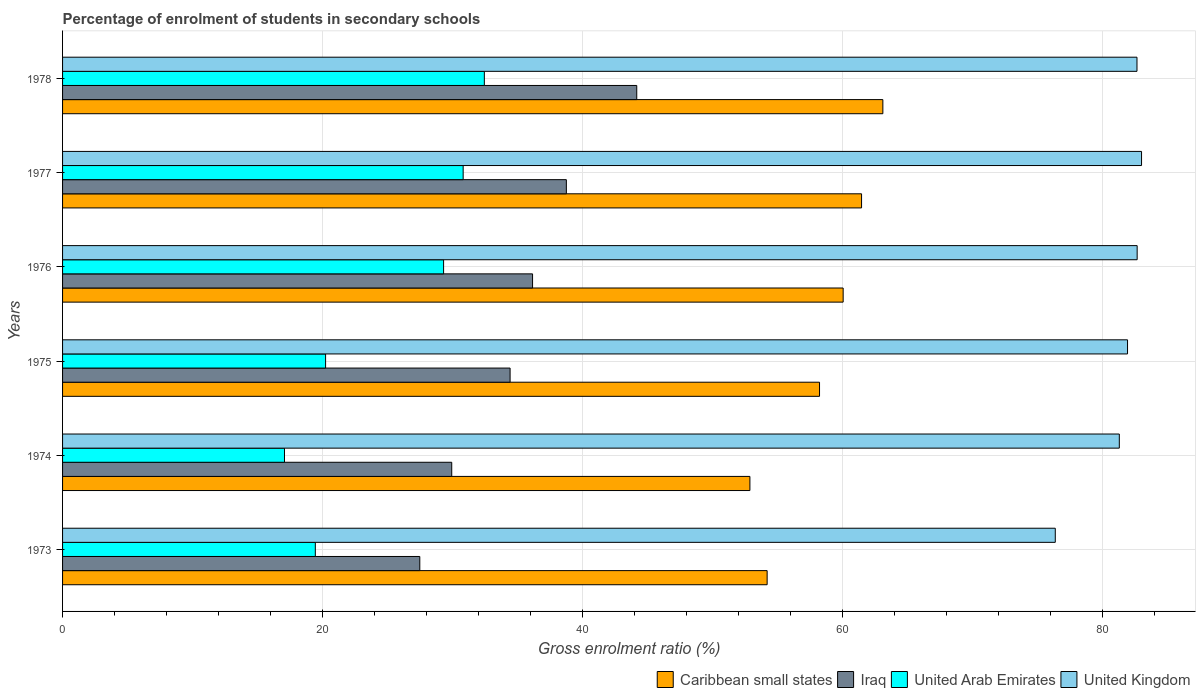How many groups of bars are there?
Your answer should be very brief. 6. In how many cases, is the number of bars for a given year not equal to the number of legend labels?
Provide a short and direct response. 0. What is the percentage of students enrolled in secondary schools in Caribbean small states in 1975?
Provide a short and direct response. 58.23. Across all years, what is the maximum percentage of students enrolled in secondary schools in United Kingdom?
Provide a succinct answer. 83. Across all years, what is the minimum percentage of students enrolled in secondary schools in United Arab Emirates?
Offer a very short reply. 17.07. In which year was the percentage of students enrolled in secondary schools in Iraq maximum?
Offer a very short reply. 1978. In which year was the percentage of students enrolled in secondary schools in Iraq minimum?
Give a very brief answer. 1973. What is the total percentage of students enrolled in secondary schools in Caribbean small states in the graph?
Ensure brevity in your answer.  349.92. What is the difference between the percentage of students enrolled in secondary schools in United Kingdom in 1974 and that in 1977?
Ensure brevity in your answer.  -1.71. What is the difference between the percentage of students enrolled in secondary schools in United Kingdom in 1977 and the percentage of students enrolled in secondary schools in Caribbean small states in 1974?
Provide a short and direct response. 30.13. What is the average percentage of students enrolled in secondary schools in United Arab Emirates per year?
Give a very brief answer. 24.89. In the year 1973, what is the difference between the percentage of students enrolled in secondary schools in United Arab Emirates and percentage of students enrolled in secondary schools in Caribbean small states?
Ensure brevity in your answer.  -34.76. What is the ratio of the percentage of students enrolled in secondary schools in United Kingdom in 1975 to that in 1977?
Offer a terse response. 0.99. Is the percentage of students enrolled in secondary schools in United Arab Emirates in 1973 less than that in 1975?
Offer a very short reply. Yes. Is the difference between the percentage of students enrolled in secondary schools in United Arab Emirates in 1975 and 1977 greater than the difference between the percentage of students enrolled in secondary schools in Caribbean small states in 1975 and 1977?
Provide a succinct answer. No. What is the difference between the highest and the second highest percentage of students enrolled in secondary schools in United Arab Emirates?
Give a very brief answer. 1.63. What is the difference between the highest and the lowest percentage of students enrolled in secondary schools in United Arab Emirates?
Make the answer very short. 15.37. Is the sum of the percentage of students enrolled in secondary schools in United Kingdom in 1973 and 1977 greater than the maximum percentage of students enrolled in secondary schools in United Arab Emirates across all years?
Offer a terse response. Yes. What does the 2nd bar from the top in 1976 represents?
Your answer should be compact. United Arab Emirates. What does the 1st bar from the bottom in 1974 represents?
Give a very brief answer. Caribbean small states. Is it the case that in every year, the sum of the percentage of students enrolled in secondary schools in United Kingdom and percentage of students enrolled in secondary schools in United Arab Emirates is greater than the percentage of students enrolled in secondary schools in Caribbean small states?
Keep it short and to the point. Yes. How many bars are there?
Keep it short and to the point. 24. How many years are there in the graph?
Your answer should be compact. 6. Does the graph contain any zero values?
Provide a short and direct response. No. Does the graph contain grids?
Make the answer very short. Yes. Where does the legend appear in the graph?
Give a very brief answer. Bottom right. What is the title of the graph?
Offer a very short reply. Percentage of enrolment of students in secondary schools. Does "Spain" appear as one of the legend labels in the graph?
Offer a terse response. No. What is the Gross enrolment ratio (%) of Caribbean small states in 1973?
Keep it short and to the point. 54.2. What is the Gross enrolment ratio (%) of Iraq in 1973?
Ensure brevity in your answer.  27.48. What is the Gross enrolment ratio (%) in United Arab Emirates in 1973?
Your answer should be compact. 19.44. What is the Gross enrolment ratio (%) of United Kingdom in 1973?
Keep it short and to the point. 76.37. What is the Gross enrolment ratio (%) in Caribbean small states in 1974?
Keep it short and to the point. 52.88. What is the Gross enrolment ratio (%) of Iraq in 1974?
Keep it short and to the point. 29.94. What is the Gross enrolment ratio (%) of United Arab Emirates in 1974?
Ensure brevity in your answer.  17.07. What is the Gross enrolment ratio (%) in United Kingdom in 1974?
Provide a succinct answer. 81.29. What is the Gross enrolment ratio (%) in Caribbean small states in 1975?
Your answer should be very brief. 58.23. What is the Gross enrolment ratio (%) of Iraq in 1975?
Your answer should be very brief. 34.43. What is the Gross enrolment ratio (%) in United Arab Emirates in 1975?
Offer a terse response. 20.23. What is the Gross enrolment ratio (%) in United Kingdom in 1975?
Provide a short and direct response. 81.92. What is the Gross enrolment ratio (%) of Caribbean small states in 1976?
Your answer should be very brief. 60.05. What is the Gross enrolment ratio (%) of Iraq in 1976?
Your answer should be compact. 36.16. What is the Gross enrolment ratio (%) in United Arab Emirates in 1976?
Keep it short and to the point. 29.31. What is the Gross enrolment ratio (%) of United Kingdom in 1976?
Your response must be concise. 82.66. What is the Gross enrolment ratio (%) in Caribbean small states in 1977?
Your answer should be very brief. 61.46. What is the Gross enrolment ratio (%) of Iraq in 1977?
Provide a short and direct response. 38.76. What is the Gross enrolment ratio (%) of United Arab Emirates in 1977?
Offer a very short reply. 30.82. What is the Gross enrolment ratio (%) of United Kingdom in 1977?
Give a very brief answer. 83. What is the Gross enrolment ratio (%) of Caribbean small states in 1978?
Keep it short and to the point. 63.1. What is the Gross enrolment ratio (%) in Iraq in 1978?
Provide a short and direct response. 44.17. What is the Gross enrolment ratio (%) in United Arab Emirates in 1978?
Offer a very short reply. 32.45. What is the Gross enrolment ratio (%) of United Kingdom in 1978?
Offer a very short reply. 82.65. Across all years, what is the maximum Gross enrolment ratio (%) of Caribbean small states?
Offer a terse response. 63.1. Across all years, what is the maximum Gross enrolment ratio (%) of Iraq?
Your response must be concise. 44.17. Across all years, what is the maximum Gross enrolment ratio (%) in United Arab Emirates?
Give a very brief answer. 32.45. Across all years, what is the maximum Gross enrolment ratio (%) of United Kingdom?
Offer a very short reply. 83. Across all years, what is the minimum Gross enrolment ratio (%) in Caribbean small states?
Offer a terse response. 52.88. Across all years, what is the minimum Gross enrolment ratio (%) of Iraq?
Ensure brevity in your answer.  27.48. Across all years, what is the minimum Gross enrolment ratio (%) of United Arab Emirates?
Offer a very short reply. 17.07. Across all years, what is the minimum Gross enrolment ratio (%) of United Kingdom?
Ensure brevity in your answer.  76.37. What is the total Gross enrolment ratio (%) of Caribbean small states in the graph?
Your response must be concise. 349.92. What is the total Gross enrolment ratio (%) in Iraq in the graph?
Make the answer very short. 210.93. What is the total Gross enrolment ratio (%) of United Arab Emirates in the graph?
Your answer should be very brief. 149.32. What is the total Gross enrolment ratio (%) of United Kingdom in the graph?
Give a very brief answer. 487.9. What is the difference between the Gross enrolment ratio (%) of Caribbean small states in 1973 and that in 1974?
Your response must be concise. 1.33. What is the difference between the Gross enrolment ratio (%) in Iraq in 1973 and that in 1974?
Give a very brief answer. -2.46. What is the difference between the Gross enrolment ratio (%) of United Arab Emirates in 1973 and that in 1974?
Make the answer very short. 2.37. What is the difference between the Gross enrolment ratio (%) of United Kingdom in 1973 and that in 1974?
Keep it short and to the point. -4.93. What is the difference between the Gross enrolment ratio (%) of Caribbean small states in 1973 and that in 1975?
Ensure brevity in your answer.  -4.03. What is the difference between the Gross enrolment ratio (%) in Iraq in 1973 and that in 1975?
Give a very brief answer. -6.95. What is the difference between the Gross enrolment ratio (%) of United Arab Emirates in 1973 and that in 1975?
Your answer should be compact. -0.79. What is the difference between the Gross enrolment ratio (%) in United Kingdom in 1973 and that in 1975?
Your answer should be very brief. -5.56. What is the difference between the Gross enrolment ratio (%) in Caribbean small states in 1973 and that in 1976?
Offer a very short reply. -5.85. What is the difference between the Gross enrolment ratio (%) of Iraq in 1973 and that in 1976?
Make the answer very short. -8.67. What is the difference between the Gross enrolment ratio (%) in United Arab Emirates in 1973 and that in 1976?
Provide a succinct answer. -9.87. What is the difference between the Gross enrolment ratio (%) of United Kingdom in 1973 and that in 1976?
Provide a short and direct response. -6.3. What is the difference between the Gross enrolment ratio (%) of Caribbean small states in 1973 and that in 1977?
Offer a very short reply. -7.26. What is the difference between the Gross enrolment ratio (%) in Iraq in 1973 and that in 1977?
Keep it short and to the point. -11.27. What is the difference between the Gross enrolment ratio (%) in United Arab Emirates in 1973 and that in 1977?
Offer a very short reply. -11.37. What is the difference between the Gross enrolment ratio (%) in United Kingdom in 1973 and that in 1977?
Provide a short and direct response. -6.64. What is the difference between the Gross enrolment ratio (%) in Caribbean small states in 1973 and that in 1978?
Provide a short and direct response. -8.9. What is the difference between the Gross enrolment ratio (%) of Iraq in 1973 and that in 1978?
Your answer should be very brief. -16.69. What is the difference between the Gross enrolment ratio (%) in United Arab Emirates in 1973 and that in 1978?
Your answer should be very brief. -13. What is the difference between the Gross enrolment ratio (%) in United Kingdom in 1973 and that in 1978?
Give a very brief answer. -6.29. What is the difference between the Gross enrolment ratio (%) in Caribbean small states in 1974 and that in 1975?
Your answer should be very brief. -5.36. What is the difference between the Gross enrolment ratio (%) in Iraq in 1974 and that in 1975?
Keep it short and to the point. -4.49. What is the difference between the Gross enrolment ratio (%) of United Arab Emirates in 1974 and that in 1975?
Provide a succinct answer. -3.16. What is the difference between the Gross enrolment ratio (%) in United Kingdom in 1974 and that in 1975?
Provide a short and direct response. -0.63. What is the difference between the Gross enrolment ratio (%) in Caribbean small states in 1974 and that in 1976?
Your response must be concise. -7.17. What is the difference between the Gross enrolment ratio (%) in Iraq in 1974 and that in 1976?
Your response must be concise. -6.22. What is the difference between the Gross enrolment ratio (%) of United Arab Emirates in 1974 and that in 1976?
Ensure brevity in your answer.  -12.24. What is the difference between the Gross enrolment ratio (%) of United Kingdom in 1974 and that in 1976?
Make the answer very short. -1.37. What is the difference between the Gross enrolment ratio (%) of Caribbean small states in 1974 and that in 1977?
Ensure brevity in your answer.  -8.59. What is the difference between the Gross enrolment ratio (%) of Iraq in 1974 and that in 1977?
Offer a terse response. -8.82. What is the difference between the Gross enrolment ratio (%) in United Arab Emirates in 1974 and that in 1977?
Provide a short and direct response. -13.75. What is the difference between the Gross enrolment ratio (%) in United Kingdom in 1974 and that in 1977?
Make the answer very short. -1.71. What is the difference between the Gross enrolment ratio (%) of Caribbean small states in 1974 and that in 1978?
Your answer should be very brief. -10.23. What is the difference between the Gross enrolment ratio (%) of Iraq in 1974 and that in 1978?
Give a very brief answer. -14.23. What is the difference between the Gross enrolment ratio (%) in United Arab Emirates in 1974 and that in 1978?
Provide a succinct answer. -15.37. What is the difference between the Gross enrolment ratio (%) in United Kingdom in 1974 and that in 1978?
Provide a short and direct response. -1.36. What is the difference between the Gross enrolment ratio (%) in Caribbean small states in 1975 and that in 1976?
Your response must be concise. -1.82. What is the difference between the Gross enrolment ratio (%) in Iraq in 1975 and that in 1976?
Offer a terse response. -1.73. What is the difference between the Gross enrolment ratio (%) of United Arab Emirates in 1975 and that in 1976?
Provide a short and direct response. -9.08. What is the difference between the Gross enrolment ratio (%) of United Kingdom in 1975 and that in 1976?
Your answer should be very brief. -0.74. What is the difference between the Gross enrolment ratio (%) in Caribbean small states in 1975 and that in 1977?
Your answer should be very brief. -3.23. What is the difference between the Gross enrolment ratio (%) in Iraq in 1975 and that in 1977?
Make the answer very short. -4.33. What is the difference between the Gross enrolment ratio (%) in United Arab Emirates in 1975 and that in 1977?
Provide a short and direct response. -10.58. What is the difference between the Gross enrolment ratio (%) in United Kingdom in 1975 and that in 1977?
Offer a terse response. -1.08. What is the difference between the Gross enrolment ratio (%) of Caribbean small states in 1975 and that in 1978?
Provide a succinct answer. -4.87. What is the difference between the Gross enrolment ratio (%) in Iraq in 1975 and that in 1978?
Make the answer very short. -9.74. What is the difference between the Gross enrolment ratio (%) in United Arab Emirates in 1975 and that in 1978?
Your answer should be compact. -12.21. What is the difference between the Gross enrolment ratio (%) in United Kingdom in 1975 and that in 1978?
Your answer should be compact. -0.73. What is the difference between the Gross enrolment ratio (%) in Caribbean small states in 1976 and that in 1977?
Your answer should be compact. -1.42. What is the difference between the Gross enrolment ratio (%) of Iraq in 1976 and that in 1977?
Your response must be concise. -2.6. What is the difference between the Gross enrolment ratio (%) of United Arab Emirates in 1976 and that in 1977?
Give a very brief answer. -1.51. What is the difference between the Gross enrolment ratio (%) in United Kingdom in 1976 and that in 1977?
Ensure brevity in your answer.  -0.34. What is the difference between the Gross enrolment ratio (%) of Caribbean small states in 1976 and that in 1978?
Keep it short and to the point. -3.05. What is the difference between the Gross enrolment ratio (%) in Iraq in 1976 and that in 1978?
Your answer should be compact. -8.01. What is the difference between the Gross enrolment ratio (%) of United Arab Emirates in 1976 and that in 1978?
Provide a short and direct response. -3.14. What is the difference between the Gross enrolment ratio (%) in United Kingdom in 1976 and that in 1978?
Provide a short and direct response. 0.01. What is the difference between the Gross enrolment ratio (%) in Caribbean small states in 1977 and that in 1978?
Your response must be concise. -1.64. What is the difference between the Gross enrolment ratio (%) in Iraq in 1977 and that in 1978?
Offer a terse response. -5.41. What is the difference between the Gross enrolment ratio (%) of United Arab Emirates in 1977 and that in 1978?
Offer a very short reply. -1.63. What is the difference between the Gross enrolment ratio (%) of United Kingdom in 1977 and that in 1978?
Offer a very short reply. 0.35. What is the difference between the Gross enrolment ratio (%) in Caribbean small states in 1973 and the Gross enrolment ratio (%) in Iraq in 1974?
Make the answer very short. 24.26. What is the difference between the Gross enrolment ratio (%) in Caribbean small states in 1973 and the Gross enrolment ratio (%) in United Arab Emirates in 1974?
Provide a short and direct response. 37.13. What is the difference between the Gross enrolment ratio (%) of Caribbean small states in 1973 and the Gross enrolment ratio (%) of United Kingdom in 1974?
Keep it short and to the point. -27.09. What is the difference between the Gross enrolment ratio (%) of Iraq in 1973 and the Gross enrolment ratio (%) of United Arab Emirates in 1974?
Your response must be concise. 10.41. What is the difference between the Gross enrolment ratio (%) in Iraq in 1973 and the Gross enrolment ratio (%) in United Kingdom in 1974?
Ensure brevity in your answer.  -53.81. What is the difference between the Gross enrolment ratio (%) of United Arab Emirates in 1973 and the Gross enrolment ratio (%) of United Kingdom in 1974?
Offer a very short reply. -61.85. What is the difference between the Gross enrolment ratio (%) in Caribbean small states in 1973 and the Gross enrolment ratio (%) in Iraq in 1975?
Ensure brevity in your answer.  19.77. What is the difference between the Gross enrolment ratio (%) in Caribbean small states in 1973 and the Gross enrolment ratio (%) in United Arab Emirates in 1975?
Provide a succinct answer. 33.97. What is the difference between the Gross enrolment ratio (%) of Caribbean small states in 1973 and the Gross enrolment ratio (%) of United Kingdom in 1975?
Offer a very short reply. -27.72. What is the difference between the Gross enrolment ratio (%) of Iraq in 1973 and the Gross enrolment ratio (%) of United Arab Emirates in 1975?
Offer a terse response. 7.25. What is the difference between the Gross enrolment ratio (%) in Iraq in 1973 and the Gross enrolment ratio (%) in United Kingdom in 1975?
Keep it short and to the point. -54.44. What is the difference between the Gross enrolment ratio (%) in United Arab Emirates in 1973 and the Gross enrolment ratio (%) in United Kingdom in 1975?
Keep it short and to the point. -62.48. What is the difference between the Gross enrolment ratio (%) of Caribbean small states in 1973 and the Gross enrolment ratio (%) of Iraq in 1976?
Ensure brevity in your answer.  18.04. What is the difference between the Gross enrolment ratio (%) of Caribbean small states in 1973 and the Gross enrolment ratio (%) of United Arab Emirates in 1976?
Keep it short and to the point. 24.89. What is the difference between the Gross enrolment ratio (%) in Caribbean small states in 1973 and the Gross enrolment ratio (%) in United Kingdom in 1976?
Provide a succinct answer. -28.46. What is the difference between the Gross enrolment ratio (%) of Iraq in 1973 and the Gross enrolment ratio (%) of United Arab Emirates in 1976?
Provide a short and direct response. -1.83. What is the difference between the Gross enrolment ratio (%) of Iraq in 1973 and the Gross enrolment ratio (%) of United Kingdom in 1976?
Your response must be concise. -55.18. What is the difference between the Gross enrolment ratio (%) of United Arab Emirates in 1973 and the Gross enrolment ratio (%) of United Kingdom in 1976?
Give a very brief answer. -63.22. What is the difference between the Gross enrolment ratio (%) of Caribbean small states in 1973 and the Gross enrolment ratio (%) of Iraq in 1977?
Provide a short and direct response. 15.44. What is the difference between the Gross enrolment ratio (%) in Caribbean small states in 1973 and the Gross enrolment ratio (%) in United Arab Emirates in 1977?
Offer a terse response. 23.38. What is the difference between the Gross enrolment ratio (%) of Caribbean small states in 1973 and the Gross enrolment ratio (%) of United Kingdom in 1977?
Keep it short and to the point. -28.8. What is the difference between the Gross enrolment ratio (%) in Iraq in 1973 and the Gross enrolment ratio (%) in United Arab Emirates in 1977?
Ensure brevity in your answer.  -3.34. What is the difference between the Gross enrolment ratio (%) of Iraq in 1973 and the Gross enrolment ratio (%) of United Kingdom in 1977?
Give a very brief answer. -55.52. What is the difference between the Gross enrolment ratio (%) in United Arab Emirates in 1973 and the Gross enrolment ratio (%) in United Kingdom in 1977?
Your answer should be very brief. -63.56. What is the difference between the Gross enrolment ratio (%) of Caribbean small states in 1973 and the Gross enrolment ratio (%) of Iraq in 1978?
Provide a succinct answer. 10.03. What is the difference between the Gross enrolment ratio (%) of Caribbean small states in 1973 and the Gross enrolment ratio (%) of United Arab Emirates in 1978?
Make the answer very short. 21.75. What is the difference between the Gross enrolment ratio (%) in Caribbean small states in 1973 and the Gross enrolment ratio (%) in United Kingdom in 1978?
Keep it short and to the point. -28.45. What is the difference between the Gross enrolment ratio (%) in Iraq in 1973 and the Gross enrolment ratio (%) in United Arab Emirates in 1978?
Ensure brevity in your answer.  -4.97. What is the difference between the Gross enrolment ratio (%) in Iraq in 1973 and the Gross enrolment ratio (%) in United Kingdom in 1978?
Give a very brief answer. -55.17. What is the difference between the Gross enrolment ratio (%) of United Arab Emirates in 1973 and the Gross enrolment ratio (%) of United Kingdom in 1978?
Offer a terse response. -63.21. What is the difference between the Gross enrolment ratio (%) in Caribbean small states in 1974 and the Gross enrolment ratio (%) in Iraq in 1975?
Offer a very short reply. 18.45. What is the difference between the Gross enrolment ratio (%) of Caribbean small states in 1974 and the Gross enrolment ratio (%) of United Arab Emirates in 1975?
Give a very brief answer. 32.64. What is the difference between the Gross enrolment ratio (%) of Caribbean small states in 1974 and the Gross enrolment ratio (%) of United Kingdom in 1975?
Your answer should be very brief. -29.05. What is the difference between the Gross enrolment ratio (%) of Iraq in 1974 and the Gross enrolment ratio (%) of United Arab Emirates in 1975?
Provide a succinct answer. 9.7. What is the difference between the Gross enrolment ratio (%) in Iraq in 1974 and the Gross enrolment ratio (%) in United Kingdom in 1975?
Provide a succinct answer. -51.99. What is the difference between the Gross enrolment ratio (%) in United Arab Emirates in 1974 and the Gross enrolment ratio (%) in United Kingdom in 1975?
Offer a very short reply. -64.85. What is the difference between the Gross enrolment ratio (%) in Caribbean small states in 1974 and the Gross enrolment ratio (%) in Iraq in 1976?
Make the answer very short. 16.72. What is the difference between the Gross enrolment ratio (%) of Caribbean small states in 1974 and the Gross enrolment ratio (%) of United Arab Emirates in 1976?
Your answer should be compact. 23.56. What is the difference between the Gross enrolment ratio (%) in Caribbean small states in 1974 and the Gross enrolment ratio (%) in United Kingdom in 1976?
Offer a very short reply. -29.79. What is the difference between the Gross enrolment ratio (%) of Iraq in 1974 and the Gross enrolment ratio (%) of United Arab Emirates in 1976?
Provide a short and direct response. 0.63. What is the difference between the Gross enrolment ratio (%) in Iraq in 1974 and the Gross enrolment ratio (%) in United Kingdom in 1976?
Offer a terse response. -52.73. What is the difference between the Gross enrolment ratio (%) of United Arab Emirates in 1974 and the Gross enrolment ratio (%) of United Kingdom in 1976?
Provide a short and direct response. -65.59. What is the difference between the Gross enrolment ratio (%) of Caribbean small states in 1974 and the Gross enrolment ratio (%) of Iraq in 1977?
Your response must be concise. 14.12. What is the difference between the Gross enrolment ratio (%) in Caribbean small states in 1974 and the Gross enrolment ratio (%) in United Arab Emirates in 1977?
Ensure brevity in your answer.  22.06. What is the difference between the Gross enrolment ratio (%) of Caribbean small states in 1974 and the Gross enrolment ratio (%) of United Kingdom in 1977?
Your answer should be very brief. -30.13. What is the difference between the Gross enrolment ratio (%) in Iraq in 1974 and the Gross enrolment ratio (%) in United Arab Emirates in 1977?
Your answer should be very brief. -0.88. What is the difference between the Gross enrolment ratio (%) in Iraq in 1974 and the Gross enrolment ratio (%) in United Kingdom in 1977?
Provide a short and direct response. -53.06. What is the difference between the Gross enrolment ratio (%) in United Arab Emirates in 1974 and the Gross enrolment ratio (%) in United Kingdom in 1977?
Your response must be concise. -65.93. What is the difference between the Gross enrolment ratio (%) in Caribbean small states in 1974 and the Gross enrolment ratio (%) in Iraq in 1978?
Make the answer very short. 8.71. What is the difference between the Gross enrolment ratio (%) of Caribbean small states in 1974 and the Gross enrolment ratio (%) of United Arab Emirates in 1978?
Make the answer very short. 20.43. What is the difference between the Gross enrolment ratio (%) of Caribbean small states in 1974 and the Gross enrolment ratio (%) of United Kingdom in 1978?
Ensure brevity in your answer.  -29.78. What is the difference between the Gross enrolment ratio (%) in Iraq in 1974 and the Gross enrolment ratio (%) in United Arab Emirates in 1978?
Your answer should be compact. -2.51. What is the difference between the Gross enrolment ratio (%) in Iraq in 1974 and the Gross enrolment ratio (%) in United Kingdom in 1978?
Your answer should be very brief. -52.71. What is the difference between the Gross enrolment ratio (%) in United Arab Emirates in 1974 and the Gross enrolment ratio (%) in United Kingdom in 1978?
Give a very brief answer. -65.58. What is the difference between the Gross enrolment ratio (%) in Caribbean small states in 1975 and the Gross enrolment ratio (%) in Iraq in 1976?
Provide a succinct answer. 22.08. What is the difference between the Gross enrolment ratio (%) in Caribbean small states in 1975 and the Gross enrolment ratio (%) in United Arab Emirates in 1976?
Make the answer very short. 28.92. What is the difference between the Gross enrolment ratio (%) of Caribbean small states in 1975 and the Gross enrolment ratio (%) of United Kingdom in 1976?
Make the answer very short. -24.43. What is the difference between the Gross enrolment ratio (%) of Iraq in 1975 and the Gross enrolment ratio (%) of United Arab Emirates in 1976?
Keep it short and to the point. 5.12. What is the difference between the Gross enrolment ratio (%) in Iraq in 1975 and the Gross enrolment ratio (%) in United Kingdom in 1976?
Give a very brief answer. -48.24. What is the difference between the Gross enrolment ratio (%) in United Arab Emirates in 1975 and the Gross enrolment ratio (%) in United Kingdom in 1976?
Keep it short and to the point. -62.43. What is the difference between the Gross enrolment ratio (%) of Caribbean small states in 1975 and the Gross enrolment ratio (%) of Iraq in 1977?
Your response must be concise. 19.48. What is the difference between the Gross enrolment ratio (%) of Caribbean small states in 1975 and the Gross enrolment ratio (%) of United Arab Emirates in 1977?
Ensure brevity in your answer.  27.41. What is the difference between the Gross enrolment ratio (%) of Caribbean small states in 1975 and the Gross enrolment ratio (%) of United Kingdom in 1977?
Make the answer very short. -24.77. What is the difference between the Gross enrolment ratio (%) in Iraq in 1975 and the Gross enrolment ratio (%) in United Arab Emirates in 1977?
Provide a succinct answer. 3.61. What is the difference between the Gross enrolment ratio (%) in Iraq in 1975 and the Gross enrolment ratio (%) in United Kingdom in 1977?
Your answer should be compact. -48.58. What is the difference between the Gross enrolment ratio (%) of United Arab Emirates in 1975 and the Gross enrolment ratio (%) of United Kingdom in 1977?
Make the answer very short. -62.77. What is the difference between the Gross enrolment ratio (%) of Caribbean small states in 1975 and the Gross enrolment ratio (%) of Iraq in 1978?
Keep it short and to the point. 14.06. What is the difference between the Gross enrolment ratio (%) of Caribbean small states in 1975 and the Gross enrolment ratio (%) of United Arab Emirates in 1978?
Ensure brevity in your answer.  25.78. What is the difference between the Gross enrolment ratio (%) of Caribbean small states in 1975 and the Gross enrolment ratio (%) of United Kingdom in 1978?
Offer a terse response. -24.42. What is the difference between the Gross enrolment ratio (%) of Iraq in 1975 and the Gross enrolment ratio (%) of United Arab Emirates in 1978?
Provide a short and direct response. 1.98. What is the difference between the Gross enrolment ratio (%) in Iraq in 1975 and the Gross enrolment ratio (%) in United Kingdom in 1978?
Provide a short and direct response. -48.23. What is the difference between the Gross enrolment ratio (%) of United Arab Emirates in 1975 and the Gross enrolment ratio (%) of United Kingdom in 1978?
Offer a very short reply. -62.42. What is the difference between the Gross enrolment ratio (%) of Caribbean small states in 1976 and the Gross enrolment ratio (%) of Iraq in 1977?
Keep it short and to the point. 21.29. What is the difference between the Gross enrolment ratio (%) of Caribbean small states in 1976 and the Gross enrolment ratio (%) of United Arab Emirates in 1977?
Your answer should be very brief. 29.23. What is the difference between the Gross enrolment ratio (%) of Caribbean small states in 1976 and the Gross enrolment ratio (%) of United Kingdom in 1977?
Your answer should be compact. -22.95. What is the difference between the Gross enrolment ratio (%) of Iraq in 1976 and the Gross enrolment ratio (%) of United Arab Emirates in 1977?
Ensure brevity in your answer.  5.34. What is the difference between the Gross enrolment ratio (%) of Iraq in 1976 and the Gross enrolment ratio (%) of United Kingdom in 1977?
Keep it short and to the point. -46.85. What is the difference between the Gross enrolment ratio (%) in United Arab Emirates in 1976 and the Gross enrolment ratio (%) in United Kingdom in 1977?
Ensure brevity in your answer.  -53.69. What is the difference between the Gross enrolment ratio (%) of Caribbean small states in 1976 and the Gross enrolment ratio (%) of Iraq in 1978?
Offer a very short reply. 15.88. What is the difference between the Gross enrolment ratio (%) in Caribbean small states in 1976 and the Gross enrolment ratio (%) in United Arab Emirates in 1978?
Your response must be concise. 27.6. What is the difference between the Gross enrolment ratio (%) of Caribbean small states in 1976 and the Gross enrolment ratio (%) of United Kingdom in 1978?
Your answer should be compact. -22.6. What is the difference between the Gross enrolment ratio (%) of Iraq in 1976 and the Gross enrolment ratio (%) of United Arab Emirates in 1978?
Your answer should be compact. 3.71. What is the difference between the Gross enrolment ratio (%) in Iraq in 1976 and the Gross enrolment ratio (%) in United Kingdom in 1978?
Keep it short and to the point. -46.5. What is the difference between the Gross enrolment ratio (%) of United Arab Emirates in 1976 and the Gross enrolment ratio (%) of United Kingdom in 1978?
Your answer should be compact. -53.34. What is the difference between the Gross enrolment ratio (%) in Caribbean small states in 1977 and the Gross enrolment ratio (%) in Iraq in 1978?
Your answer should be compact. 17.29. What is the difference between the Gross enrolment ratio (%) in Caribbean small states in 1977 and the Gross enrolment ratio (%) in United Arab Emirates in 1978?
Your answer should be very brief. 29.02. What is the difference between the Gross enrolment ratio (%) of Caribbean small states in 1977 and the Gross enrolment ratio (%) of United Kingdom in 1978?
Your answer should be very brief. -21.19. What is the difference between the Gross enrolment ratio (%) in Iraq in 1977 and the Gross enrolment ratio (%) in United Arab Emirates in 1978?
Provide a succinct answer. 6.31. What is the difference between the Gross enrolment ratio (%) in Iraq in 1977 and the Gross enrolment ratio (%) in United Kingdom in 1978?
Make the answer very short. -43.9. What is the difference between the Gross enrolment ratio (%) in United Arab Emirates in 1977 and the Gross enrolment ratio (%) in United Kingdom in 1978?
Keep it short and to the point. -51.84. What is the average Gross enrolment ratio (%) in Caribbean small states per year?
Your response must be concise. 58.32. What is the average Gross enrolment ratio (%) of Iraq per year?
Make the answer very short. 35.15. What is the average Gross enrolment ratio (%) in United Arab Emirates per year?
Keep it short and to the point. 24.89. What is the average Gross enrolment ratio (%) of United Kingdom per year?
Provide a short and direct response. 81.32. In the year 1973, what is the difference between the Gross enrolment ratio (%) in Caribbean small states and Gross enrolment ratio (%) in Iraq?
Your response must be concise. 26.72. In the year 1973, what is the difference between the Gross enrolment ratio (%) in Caribbean small states and Gross enrolment ratio (%) in United Arab Emirates?
Offer a terse response. 34.76. In the year 1973, what is the difference between the Gross enrolment ratio (%) in Caribbean small states and Gross enrolment ratio (%) in United Kingdom?
Make the answer very short. -22.17. In the year 1973, what is the difference between the Gross enrolment ratio (%) of Iraq and Gross enrolment ratio (%) of United Arab Emirates?
Keep it short and to the point. 8.04. In the year 1973, what is the difference between the Gross enrolment ratio (%) in Iraq and Gross enrolment ratio (%) in United Kingdom?
Provide a succinct answer. -48.89. In the year 1973, what is the difference between the Gross enrolment ratio (%) in United Arab Emirates and Gross enrolment ratio (%) in United Kingdom?
Keep it short and to the point. -56.92. In the year 1974, what is the difference between the Gross enrolment ratio (%) in Caribbean small states and Gross enrolment ratio (%) in Iraq?
Your answer should be compact. 22.94. In the year 1974, what is the difference between the Gross enrolment ratio (%) in Caribbean small states and Gross enrolment ratio (%) in United Arab Emirates?
Provide a succinct answer. 35.8. In the year 1974, what is the difference between the Gross enrolment ratio (%) of Caribbean small states and Gross enrolment ratio (%) of United Kingdom?
Ensure brevity in your answer.  -28.42. In the year 1974, what is the difference between the Gross enrolment ratio (%) of Iraq and Gross enrolment ratio (%) of United Arab Emirates?
Give a very brief answer. 12.87. In the year 1974, what is the difference between the Gross enrolment ratio (%) in Iraq and Gross enrolment ratio (%) in United Kingdom?
Make the answer very short. -51.35. In the year 1974, what is the difference between the Gross enrolment ratio (%) of United Arab Emirates and Gross enrolment ratio (%) of United Kingdom?
Keep it short and to the point. -64.22. In the year 1975, what is the difference between the Gross enrolment ratio (%) of Caribbean small states and Gross enrolment ratio (%) of Iraq?
Offer a very short reply. 23.8. In the year 1975, what is the difference between the Gross enrolment ratio (%) in Caribbean small states and Gross enrolment ratio (%) in United Arab Emirates?
Provide a succinct answer. 38. In the year 1975, what is the difference between the Gross enrolment ratio (%) of Caribbean small states and Gross enrolment ratio (%) of United Kingdom?
Offer a terse response. -23.69. In the year 1975, what is the difference between the Gross enrolment ratio (%) of Iraq and Gross enrolment ratio (%) of United Arab Emirates?
Give a very brief answer. 14.19. In the year 1975, what is the difference between the Gross enrolment ratio (%) of Iraq and Gross enrolment ratio (%) of United Kingdom?
Offer a very short reply. -47.5. In the year 1975, what is the difference between the Gross enrolment ratio (%) in United Arab Emirates and Gross enrolment ratio (%) in United Kingdom?
Your answer should be compact. -61.69. In the year 1976, what is the difference between the Gross enrolment ratio (%) of Caribbean small states and Gross enrolment ratio (%) of Iraq?
Ensure brevity in your answer.  23.89. In the year 1976, what is the difference between the Gross enrolment ratio (%) in Caribbean small states and Gross enrolment ratio (%) in United Arab Emirates?
Keep it short and to the point. 30.74. In the year 1976, what is the difference between the Gross enrolment ratio (%) in Caribbean small states and Gross enrolment ratio (%) in United Kingdom?
Offer a very short reply. -22.62. In the year 1976, what is the difference between the Gross enrolment ratio (%) in Iraq and Gross enrolment ratio (%) in United Arab Emirates?
Keep it short and to the point. 6.84. In the year 1976, what is the difference between the Gross enrolment ratio (%) of Iraq and Gross enrolment ratio (%) of United Kingdom?
Keep it short and to the point. -46.51. In the year 1976, what is the difference between the Gross enrolment ratio (%) in United Arab Emirates and Gross enrolment ratio (%) in United Kingdom?
Offer a very short reply. -53.35. In the year 1977, what is the difference between the Gross enrolment ratio (%) in Caribbean small states and Gross enrolment ratio (%) in Iraq?
Provide a succinct answer. 22.71. In the year 1977, what is the difference between the Gross enrolment ratio (%) of Caribbean small states and Gross enrolment ratio (%) of United Arab Emirates?
Provide a succinct answer. 30.65. In the year 1977, what is the difference between the Gross enrolment ratio (%) in Caribbean small states and Gross enrolment ratio (%) in United Kingdom?
Your answer should be compact. -21.54. In the year 1977, what is the difference between the Gross enrolment ratio (%) in Iraq and Gross enrolment ratio (%) in United Arab Emirates?
Offer a terse response. 7.94. In the year 1977, what is the difference between the Gross enrolment ratio (%) in Iraq and Gross enrolment ratio (%) in United Kingdom?
Offer a very short reply. -44.25. In the year 1977, what is the difference between the Gross enrolment ratio (%) in United Arab Emirates and Gross enrolment ratio (%) in United Kingdom?
Keep it short and to the point. -52.19. In the year 1978, what is the difference between the Gross enrolment ratio (%) of Caribbean small states and Gross enrolment ratio (%) of Iraq?
Your answer should be compact. 18.93. In the year 1978, what is the difference between the Gross enrolment ratio (%) in Caribbean small states and Gross enrolment ratio (%) in United Arab Emirates?
Your answer should be compact. 30.66. In the year 1978, what is the difference between the Gross enrolment ratio (%) of Caribbean small states and Gross enrolment ratio (%) of United Kingdom?
Offer a very short reply. -19.55. In the year 1978, what is the difference between the Gross enrolment ratio (%) of Iraq and Gross enrolment ratio (%) of United Arab Emirates?
Give a very brief answer. 11.72. In the year 1978, what is the difference between the Gross enrolment ratio (%) in Iraq and Gross enrolment ratio (%) in United Kingdom?
Keep it short and to the point. -38.48. In the year 1978, what is the difference between the Gross enrolment ratio (%) of United Arab Emirates and Gross enrolment ratio (%) of United Kingdom?
Offer a terse response. -50.21. What is the ratio of the Gross enrolment ratio (%) in Caribbean small states in 1973 to that in 1974?
Offer a very short reply. 1.03. What is the ratio of the Gross enrolment ratio (%) in Iraq in 1973 to that in 1974?
Provide a succinct answer. 0.92. What is the ratio of the Gross enrolment ratio (%) of United Arab Emirates in 1973 to that in 1974?
Ensure brevity in your answer.  1.14. What is the ratio of the Gross enrolment ratio (%) of United Kingdom in 1973 to that in 1974?
Ensure brevity in your answer.  0.94. What is the ratio of the Gross enrolment ratio (%) in Caribbean small states in 1973 to that in 1975?
Your answer should be very brief. 0.93. What is the ratio of the Gross enrolment ratio (%) of Iraq in 1973 to that in 1975?
Offer a very short reply. 0.8. What is the ratio of the Gross enrolment ratio (%) in United Arab Emirates in 1973 to that in 1975?
Keep it short and to the point. 0.96. What is the ratio of the Gross enrolment ratio (%) of United Kingdom in 1973 to that in 1975?
Make the answer very short. 0.93. What is the ratio of the Gross enrolment ratio (%) of Caribbean small states in 1973 to that in 1976?
Offer a terse response. 0.9. What is the ratio of the Gross enrolment ratio (%) in Iraq in 1973 to that in 1976?
Your response must be concise. 0.76. What is the ratio of the Gross enrolment ratio (%) in United Arab Emirates in 1973 to that in 1976?
Make the answer very short. 0.66. What is the ratio of the Gross enrolment ratio (%) of United Kingdom in 1973 to that in 1976?
Make the answer very short. 0.92. What is the ratio of the Gross enrolment ratio (%) of Caribbean small states in 1973 to that in 1977?
Your response must be concise. 0.88. What is the ratio of the Gross enrolment ratio (%) of Iraq in 1973 to that in 1977?
Ensure brevity in your answer.  0.71. What is the ratio of the Gross enrolment ratio (%) of United Arab Emirates in 1973 to that in 1977?
Provide a short and direct response. 0.63. What is the ratio of the Gross enrolment ratio (%) in Caribbean small states in 1973 to that in 1978?
Keep it short and to the point. 0.86. What is the ratio of the Gross enrolment ratio (%) in Iraq in 1973 to that in 1978?
Provide a succinct answer. 0.62. What is the ratio of the Gross enrolment ratio (%) in United Arab Emirates in 1973 to that in 1978?
Provide a short and direct response. 0.6. What is the ratio of the Gross enrolment ratio (%) in United Kingdom in 1973 to that in 1978?
Your answer should be very brief. 0.92. What is the ratio of the Gross enrolment ratio (%) of Caribbean small states in 1974 to that in 1975?
Your response must be concise. 0.91. What is the ratio of the Gross enrolment ratio (%) in Iraq in 1974 to that in 1975?
Your response must be concise. 0.87. What is the ratio of the Gross enrolment ratio (%) of United Arab Emirates in 1974 to that in 1975?
Give a very brief answer. 0.84. What is the ratio of the Gross enrolment ratio (%) of United Kingdom in 1974 to that in 1975?
Provide a succinct answer. 0.99. What is the ratio of the Gross enrolment ratio (%) in Caribbean small states in 1974 to that in 1976?
Provide a short and direct response. 0.88. What is the ratio of the Gross enrolment ratio (%) in Iraq in 1974 to that in 1976?
Provide a short and direct response. 0.83. What is the ratio of the Gross enrolment ratio (%) in United Arab Emirates in 1974 to that in 1976?
Your answer should be compact. 0.58. What is the ratio of the Gross enrolment ratio (%) of United Kingdom in 1974 to that in 1976?
Ensure brevity in your answer.  0.98. What is the ratio of the Gross enrolment ratio (%) in Caribbean small states in 1974 to that in 1977?
Offer a terse response. 0.86. What is the ratio of the Gross enrolment ratio (%) of Iraq in 1974 to that in 1977?
Provide a short and direct response. 0.77. What is the ratio of the Gross enrolment ratio (%) of United Arab Emirates in 1974 to that in 1977?
Your answer should be very brief. 0.55. What is the ratio of the Gross enrolment ratio (%) of United Kingdom in 1974 to that in 1977?
Keep it short and to the point. 0.98. What is the ratio of the Gross enrolment ratio (%) in Caribbean small states in 1974 to that in 1978?
Offer a terse response. 0.84. What is the ratio of the Gross enrolment ratio (%) in Iraq in 1974 to that in 1978?
Make the answer very short. 0.68. What is the ratio of the Gross enrolment ratio (%) in United Arab Emirates in 1974 to that in 1978?
Provide a succinct answer. 0.53. What is the ratio of the Gross enrolment ratio (%) of United Kingdom in 1974 to that in 1978?
Provide a succinct answer. 0.98. What is the ratio of the Gross enrolment ratio (%) of Caribbean small states in 1975 to that in 1976?
Your answer should be very brief. 0.97. What is the ratio of the Gross enrolment ratio (%) of Iraq in 1975 to that in 1976?
Offer a terse response. 0.95. What is the ratio of the Gross enrolment ratio (%) in United Arab Emirates in 1975 to that in 1976?
Offer a very short reply. 0.69. What is the ratio of the Gross enrolment ratio (%) of Caribbean small states in 1975 to that in 1977?
Give a very brief answer. 0.95. What is the ratio of the Gross enrolment ratio (%) in Iraq in 1975 to that in 1977?
Make the answer very short. 0.89. What is the ratio of the Gross enrolment ratio (%) in United Arab Emirates in 1975 to that in 1977?
Provide a succinct answer. 0.66. What is the ratio of the Gross enrolment ratio (%) in Caribbean small states in 1975 to that in 1978?
Your answer should be very brief. 0.92. What is the ratio of the Gross enrolment ratio (%) in Iraq in 1975 to that in 1978?
Make the answer very short. 0.78. What is the ratio of the Gross enrolment ratio (%) of United Arab Emirates in 1975 to that in 1978?
Provide a succinct answer. 0.62. What is the ratio of the Gross enrolment ratio (%) in Iraq in 1976 to that in 1977?
Your answer should be very brief. 0.93. What is the ratio of the Gross enrolment ratio (%) of United Arab Emirates in 1976 to that in 1977?
Ensure brevity in your answer.  0.95. What is the ratio of the Gross enrolment ratio (%) of United Kingdom in 1976 to that in 1977?
Give a very brief answer. 1. What is the ratio of the Gross enrolment ratio (%) in Caribbean small states in 1976 to that in 1978?
Provide a succinct answer. 0.95. What is the ratio of the Gross enrolment ratio (%) of Iraq in 1976 to that in 1978?
Keep it short and to the point. 0.82. What is the ratio of the Gross enrolment ratio (%) of United Arab Emirates in 1976 to that in 1978?
Your answer should be compact. 0.9. What is the ratio of the Gross enrolment ratio (%) in Iraq in 1977 to that in 1978?
Your answer should be very brief. 0.88. What is the ratio of the Gross enrolment ratio (%) of United Arab Emirates in 1977 to that in 1978?
Your answer should be very brief. 0.95. What is the ratio of the Gross enrolment ratio (%) in United Kingdom in 1977 to that in 1978?
Your answer should be very brief. 1. What is the difference between the highest and the second highest Gross enrolment ratio (%) of Caribbean small states?
Your answer should be very brief. 1.64. What is the difference between the highest and the second highest Gross enrolment ratio (%) of Iraq?
Your response must be concise. 5.41. What is the difference between the highest and the second highest Gross enrolment ratio (%) of United Arab Emirates?
Make the answer very short. 1.63. What is the difference between the highest and the second highest Gross enrolment ratio (%) of United Kingdom?
Your response must be concise. 0.34. What is the difference between the highest and the lowest Gross enrolment ratio (%) in Caribbean small states?
Keep it short and to the point. 10.23. What is the difference between the highest and the lowest Gross enrolment ratio (%) in Iraq?
Offer a very short reply. 16.69. What is the difference between the highest and the lowest Gross enrolment ratio (%) in United Arab Emirates?
Offer a very short reply. 15.37. What is the difference between the highest and the lowest Gross enrolment ratio (%) in United Kingdom?
Provide a short and direct response. 6.64. 